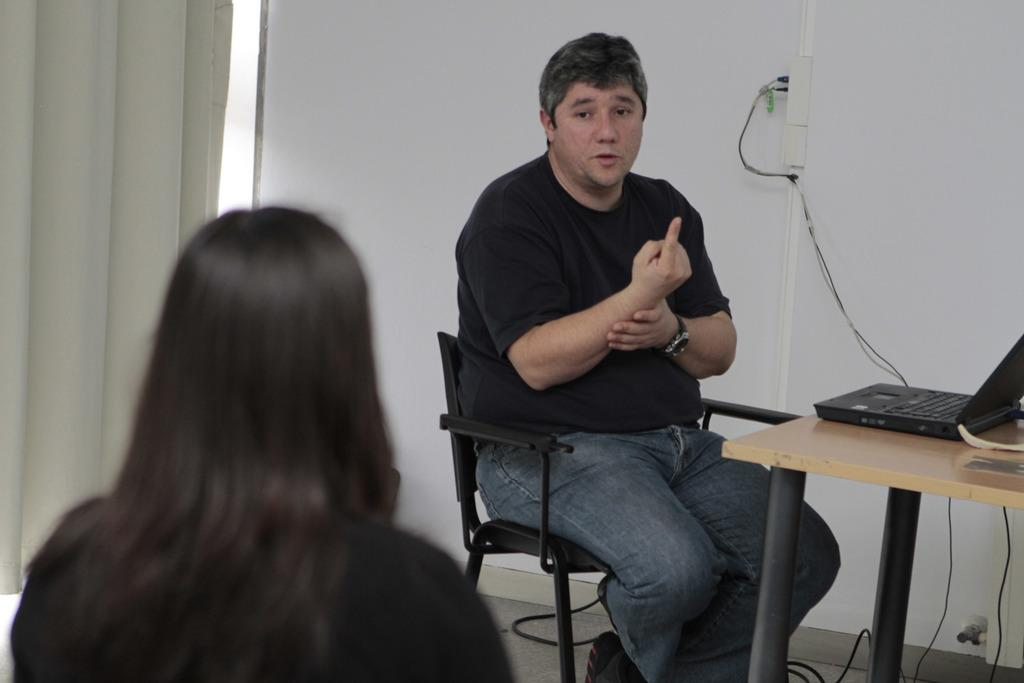What is the man in the image doing? The man is sitting on a chair and giving instructions to a woman. Where is the woman positioned in relation to the man? The woman is in front of the man. What type of furniture can be seen in the image? There is a wooden table in the image. What electronic device is on the wooden table? A laptop is present on the wooden table. What type of letters can be seen on the hall in the image? There is no hall or letters present in the image. 